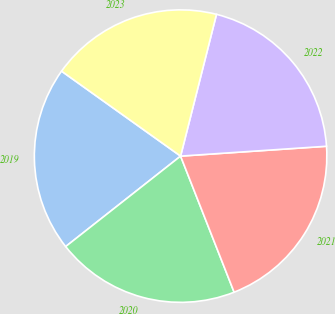Convert chart. <chart><loc_0><loc_0><loc_500><loc_500><pie_chart><fcel>2019<fcel>2020<fcel>2021<fcel>2022<fcel>2023<nl><fcel>20.48%<fcel>20.35%<fcel>20.11%<fcel>19.98%<fcel>19.08%<nl></chart> 